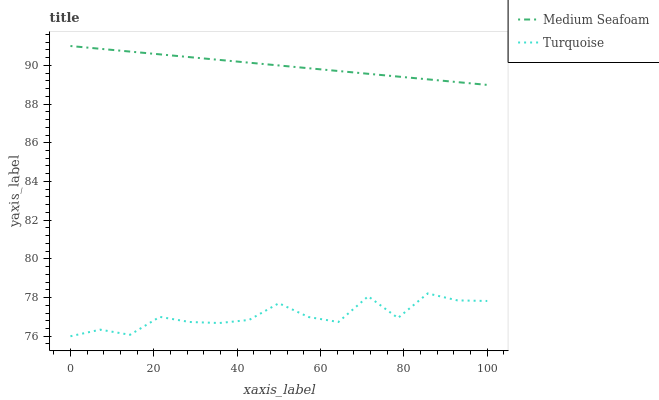Does Medium Seafoam have the minimum area under the curve?
Answer yes or no. No. Is Medium Seafoam the roughest?
Answer yes or no. No. Does Medium Seafoam have the lowest value?
Answer yes or no. No. Is Turquoise less than Medium Seafoam?
Answer yes or no. Yes. Is Medium Seafoam greater than Turquoise?
Answer yes or no. Yes. Does Turquoise intersect Medium Seafoam?
Answer yes or no. No. 